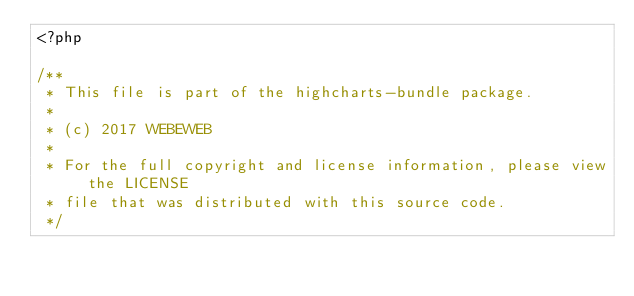Convert code to text. <code><loc_0><loc_0><loc_500><loc_500><_PHP_><?php

/**
 * This file is part of the highcharts-bundle package.
 *
 * (c) 2017 WEBEWEB
 *
 * For the full copyright and license information, please view the LICENSE
 * file that was distributed with this source code.
 */
</code> 